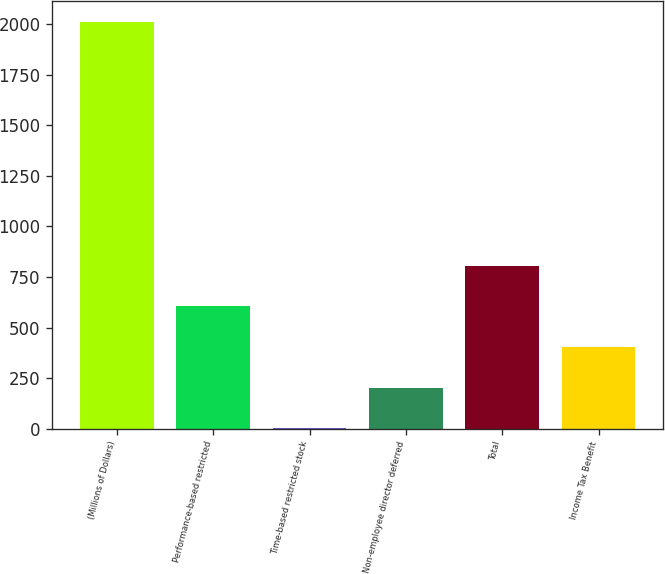Convert chart to OTSL. <chart><loc_0><loc_0><loc_500><loc_500><bar_chart><fcel>(Millions of Dollars)<fcel>Performance-based restricted<fcel>Time-based restricted stock<fcel>Non-employee director deferred<fcel>Total<fcel>Income Tax Benefit<nl><fcel>2012<fcel>604.3<fcel>1<fcel>202.1<fcel>805.4<fcel>403.2<nl></chart> 